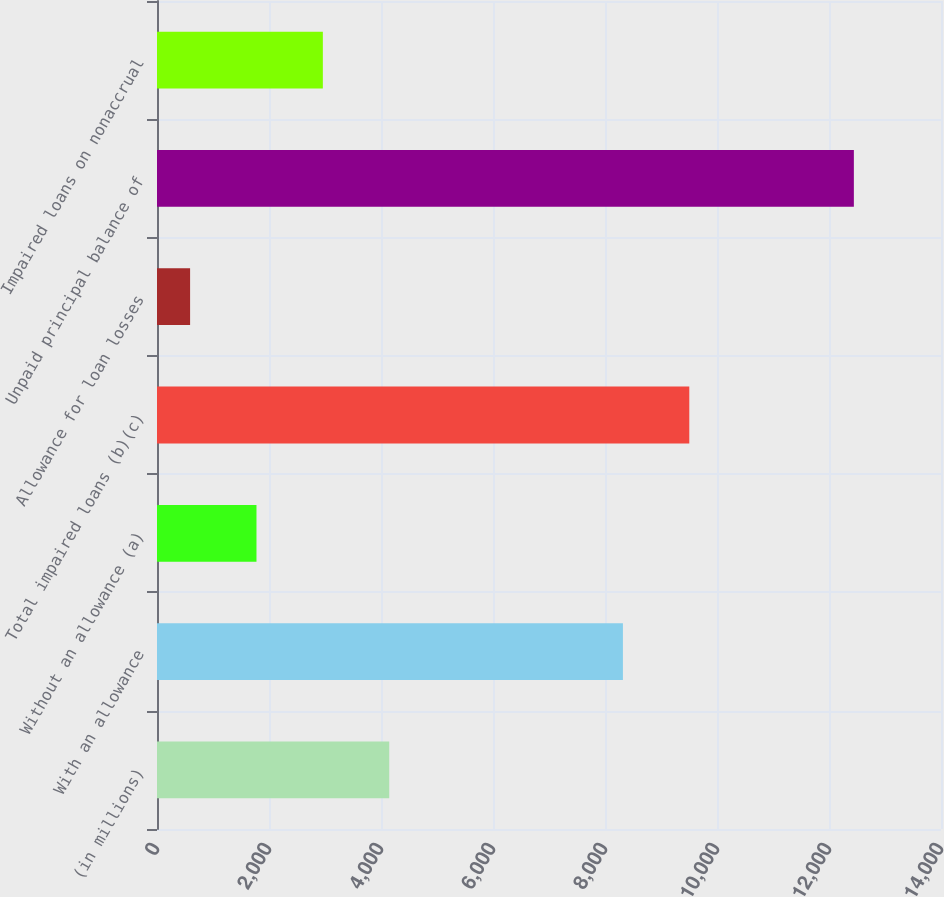Convert chart. <chart><loc_0><loc_0><loc_500><loc_500><bar_chart><fcel>(in millions)<fcel>With an allowance<fcel>Without an allowance (a)<fcel>Total impaired loans (b)(c)<fcel>Allowance for loan losses<fcel>Unpaid principal balance of<fcel>Impaired loans on nonaccrual<nl><fcel>4146.9<fcel>8320<fcel>1776.3<fcel>9505.3<fcel>591<fcel>12444<fcel>2961.6<nl></chart> 